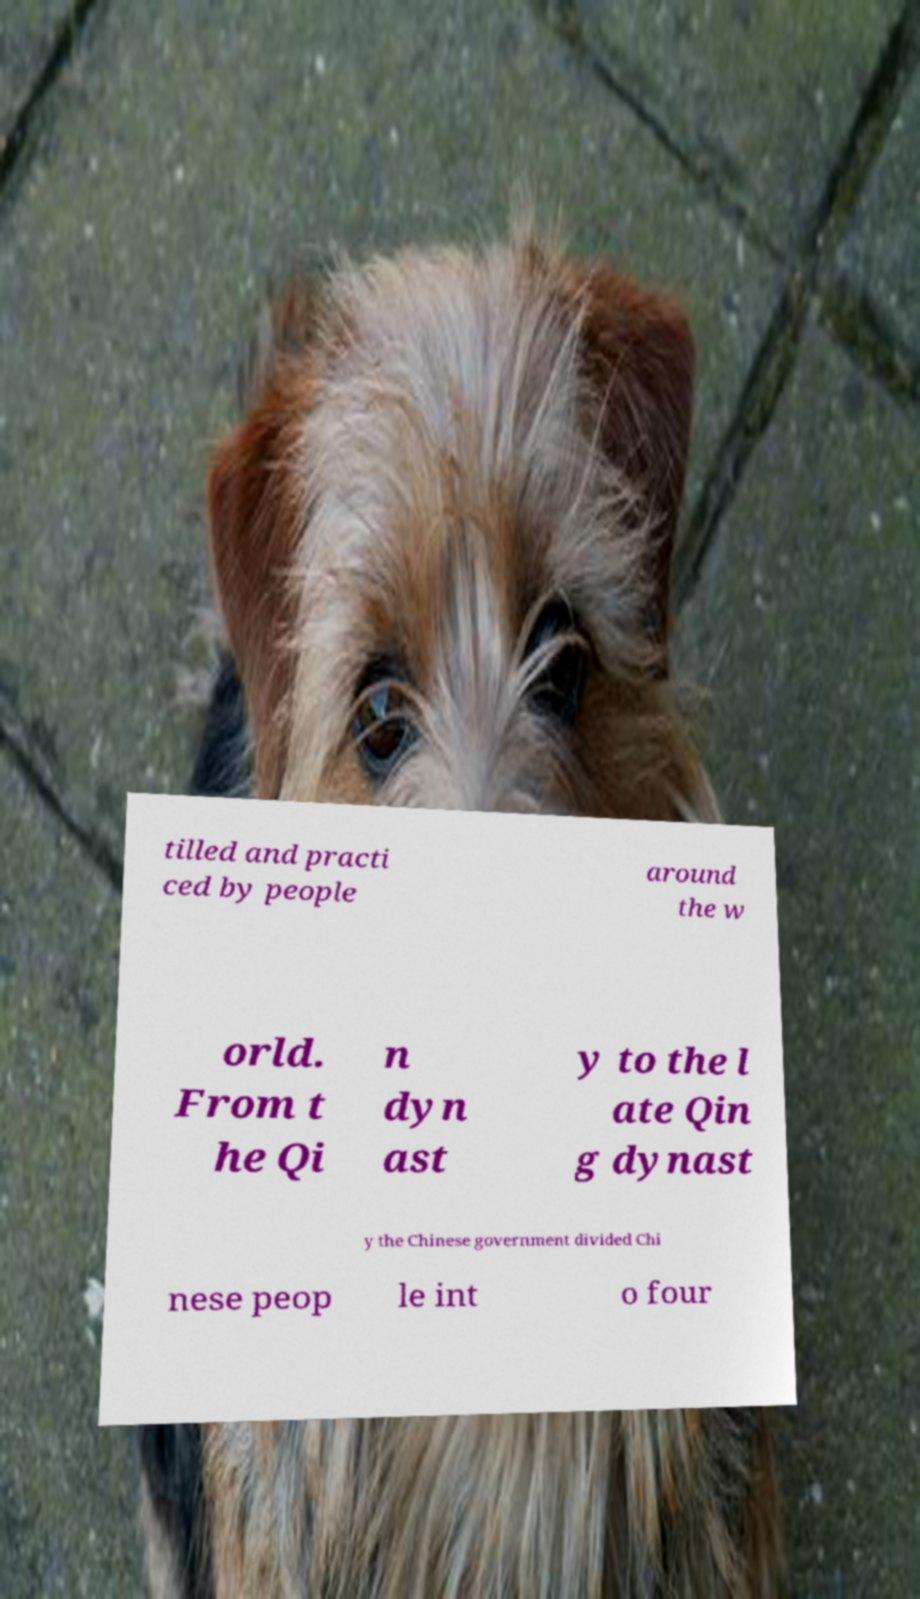Could you assist in decoding the text presented in this image and type it out clearly? tilled and practi ced by people around the w orld. From t he Qi n dyn ast y to the l ate Qin g dynast y the Chinese government divided Chi nese peop le int o four 